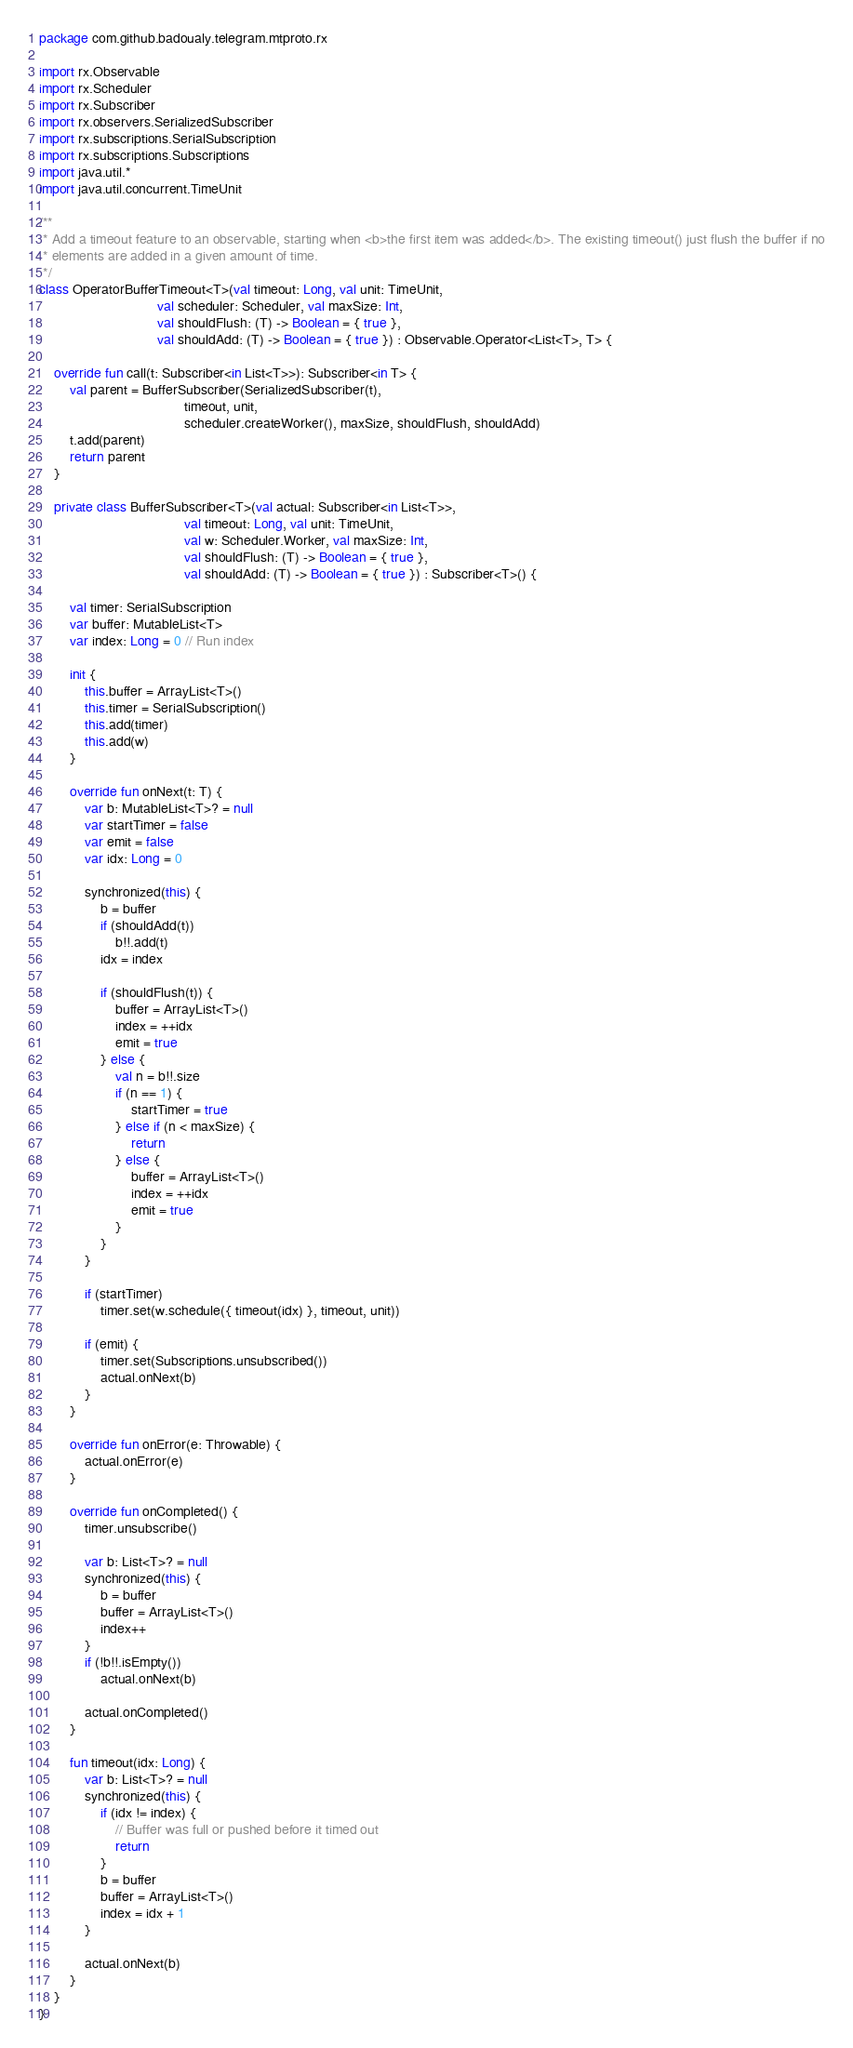<code> <loc_0><loc_0><loc_500><loc_500><_Kotlin_>package com.github.badoualy.telegram.mtproto.rx

import rx.Observable
import rx.Scheduler
import rx.Subscriber
import rx.observers.SerializedSubscriber
import rx.subscriptions.SerialSubscription
import rx.subscriptions.Subscriptions
import java.util.*
import java.util.concurrent.TimeUnit

/**
 * Add a timeout feature to an observable, starting when <b>the first item was added</b>. The existing timeout() just flush the buffer if no
 * elements are added in a given amount of time.
 */
class OperatorBufferTimeout<T>(val timeout: Long, val unit: TimeUnit,
                               val scheduler: Scheduler, val maxSize: Int,
                               val shouldFlush: (T) -> Boolean = { true },
                               val shouldAdd: (T) -> Boolean = { true }) : Observable.Operator<List<T>, T> {

    override fun call(t: Subscriber<in List<T>>): Subscriber<in T> {
        val parent = BufferSubscriber(SerializedSubscriber(t),
                                      timeout, unit,
                                      scheduler.createWorker(), maxSize, shouldFlush, shouldAdd)
        t.add(parent)
        return parent
    }

    private class BufferSubscriber<T>(val actual: Subscriber<in List<T>>,
                                      val timeout: Long, val unit: TimeUnit,
                                      val w: Scheduler.Worker, val maxSize: Int,
                                      val shouldFlush: (T) -> Boolean = { true },
                                      val shouldAdd: (T) -> Boolean = { true }) : Subscriber<T>() {

        val timer: SerialSubscription
        var buffer: MutableList<T>
        var index: Long = 0 // Run index

        init {
            this.buffer = ArrayList<T>()
            this.timer = SerialSubscription()
            this.add(timer)
            this.add(w)
        }

        override fun onNext(t: T) {
            var b: MutableList<T>? = null
            var startTimer = false
            var emit = false
            var idx: Long = 0

            synchronized(this) {
                b = buffer
                if (shouldAdd(t))
                    b!!.add(t)
                idx = index

                if (shouldFlush(t)) {
                    buffer = ArrayList<T>()
                    index = ++idx
                    emit = true
                } else {
                    val n = b!!.size
                    if (n == 1) {
                        startTimer = true
                    } else if (n < maxSize) {
                        return
                    } else {
                        buffer = ArrayList<T>()
                        index = ++idx
                        emit = true
                    }
                }
            }

            if (startTimer)
                timer.set(w.schedule({ timeout(idx) }, timeout, unit))

            if (emit) {
                timer.set(Subscriptions.unsubscribed())
                actual.onNext(b)
            }
        }

        override fun onError(e: Throwable) {
            actual.onError(e)
        }

        override fun onCompleted() {
            timer.unsubscribe()

            var b: List<T>? = null
            synchronized(this) {
                b = buffer
                buffer = ArrayList<T>()
                index++
            }
            if (!b!!.isEmpty())
                actual.onNext(b)

            actual.onCompleted()
        }

        fun timeout(idx: Long) {
            var b: List<T>? = null
            synchronized(this) {
                if (idx != index) {
                    // Buffer was full or pushed before it timed out
                    return
                }
                b = buffer
                buffer = ArrayList<T>()
                index = idx + 1
            }

            actual.onNext(b)
        }
    }
}</code> 